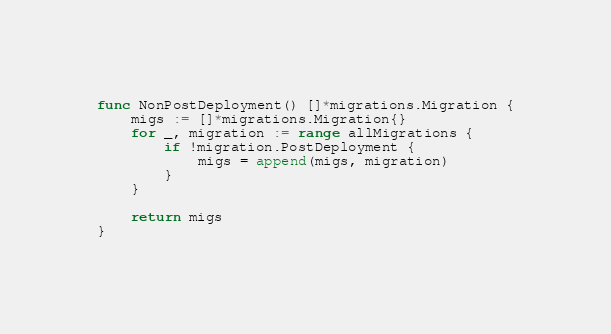Convert code to text. <code><loc_0><loc_0><loc_500><loc_500><_Go_>
func NonPostDeployment() []*migrations.Migration {
	migs := []*migrations.Migration{}
	for _, migration := range allMigrations {
		if !migration.PostDeployment {
			migs = append(migs, migration)
		}
	}

	return migs
}
</code> 